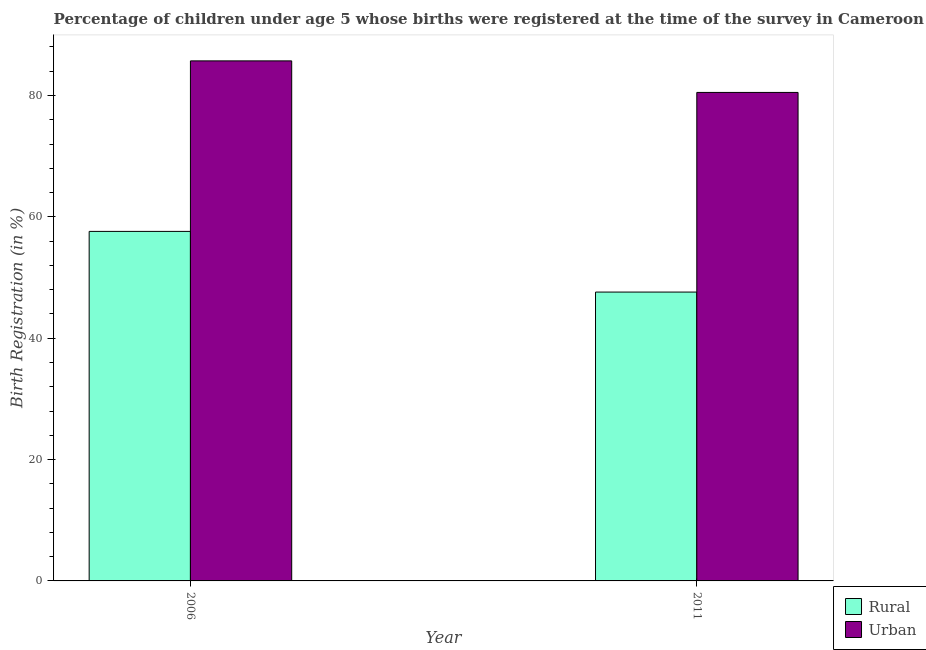How many different coloured bars are there?
Offer a very short reply. 2. Are the number of bars on each tick of the X-axis equal?
Make the answer very short. Yes. How many bars are there on the 2nd tick from the right?
Keep it short and to the point. 2. What is the label of the 2nd group of bars from the left?
Ensure brevity in your answer.  2011. What is the rural birth registration in 2006?
Your answer should be compact. 57.6. Across all years, what is the maximum rural birth registration?
Make the answer very short. 57.6. Across all years, what is the minimum rural birth registration?
Your answer should be compact. 47.6. In which year was the rural birth registration maximum?
Your answer should be very brief. 2006. What is the total urban birth registration in the graph?
Provide a succinct answer. 166.2. What is the difference between the urban birth registration in 2006 and that in 2011?
Give a very brief answer. 5.2. What is the average urban birth registration per year?
Your answer should be compact. 83.1. In the year 2011, what is the difference between the rural birth registration and urban birth registration?
Give a very brief answer. 0. What is the ratio of the urban birth registration in 2006 to that in 2011?
Make the answer very short. 1.06. What does the 2nd bar from the left in 2006 represents?
Offer a terse response. Urban. What does the 2nd bar from the right in 2011 represents?
Offer a very short reply. Rural. How many bars are there?
Keep it short and to the point. 4. How many years are there in the graph?
Your response must be concise. 2. What is the difference between two consecutive major ticks on the Y-axis?
Give a very brief answer. 20. Are the values on the major ticks of Y-axis written in scientific E-notation?
Provide a succinct answer. No. Where does the legend appear in the graph?
Provide a succinct answer. Bottom right. How are the legend labels stacked?
Offer a very short reply. Vertical. What is the title of the graph?
Keep it short and to the point. Percentage of children under age 5 whose births were registered at the time of the survey in Cameroon. Does "Private funds" appear as one of the legend labels in the graph?
Give a very brief answer. No. What is the label or title of the Y-axis?
Offer a terse response. Birth Registration (in %). What is the Birth Registration (in %) in Rural in 2006?
Provide a short and direct response. 57.6. What is the Birth Registration (in %) in Urban in 2006?
Your answer should be compact. 85.7. What is the Birth Registration (in %) in Rural in 2011?
Offer a terse response. 47.6. What is the Birth Registration (in %) of Urban in 2011?
Provide a succinct answer. 80.5. Across all years, what is the maximum Birth Registration (in %) of Rural?
Provide a short and direct response. 57.6. Across all years, what is the maximum Birth Registration (in %) in Urban?
Provide a short and direct response. 85.7. Across all years, what is the minimum Birth Registration (in %) of Rural?
Give a very brief answer. 47.6. Across all years, what is the minimum Birth Registration (in %) of Urban?
Offer a very short reply. 80.5. What is the total Birth Registration (in %) of Rural in the graph?
Keep it short and to the point. 105.2. What is the total Birth Registration (in %) of Urban in the graph?
Your answer should be compact. 166.2. What is the difference between the Birth Registration (in %) in Rural in 2006 and that in 2011?
Offer a very short reply. 10. What is the difference between the Birth Registration (in %) in Urban in 2006 and that in 2011?
Give a very brief answer. 5.2. What is the difference between the Birth Registration (in %) in Rural in 2006 and the Birth Registration (in %) in Urban in 2011?
Provide a succinct answer. -22.9. What is the average Birth Registration (in %) of Rural per year?
Keep it short and to the point. 52.6. What is the average Birth Registration (in %) in Urban per year?
Your response must be concise. 83.1. In the year 2006, what is the difference between the Birth Registration (in %) in Rural and Birth Registration (in %) in Urban?
Your answer should be very brief. -28.1. In the year 2011, what is the difference between the Birth Registration (in %) of Rural and Birth Registration (in %) of Urban?
Make the answer very short. -32.9. What is the ratio of the Birth Registration (in %) of Rural in 2006 to that in 2011?
Your answer should be very brief. 1.21. What is the ratio of the Birth Registration (in %) of Urban in 2006 to that in 2011?
Offer a terse response. 1.06. What is the difference between the highest and the second highest Birth Registration (in %) of Urban?
Offer a very short reply. 5.2. What is the difference between the highest and the lowest Birth Registration (in %) in Urban?
Provide a short and direct response. 5.2. 